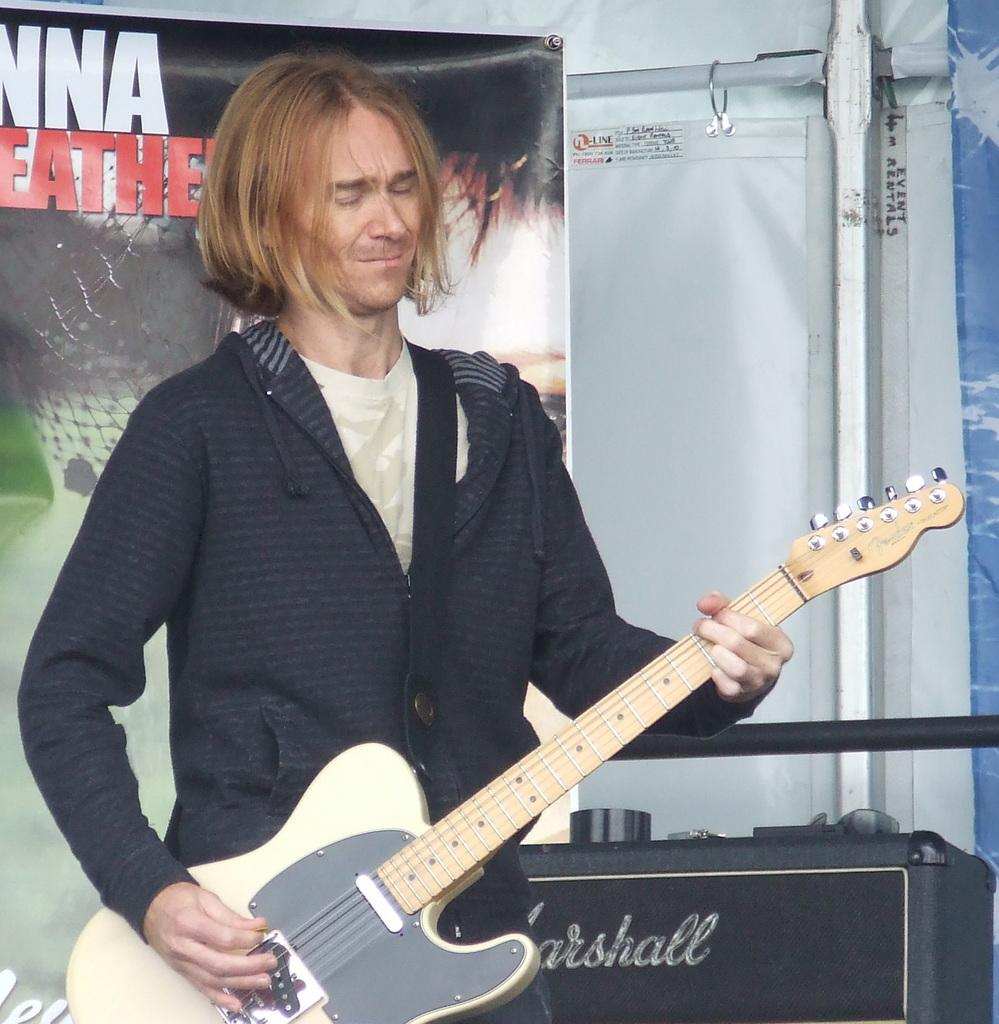Who is the person in the image? There is a man in the image. What is the man doing in the image? The man is playing a guitar. What color is the man's hair? The man has blonde hair. What is the man wearing in the image? The man is wearing a black sweater. What can be seen in the background of the image? There is a banner and a speaker in the background of the image. What direction is the ray of knowledge pointing in the image? There is no ray of knowledge present in the image. 